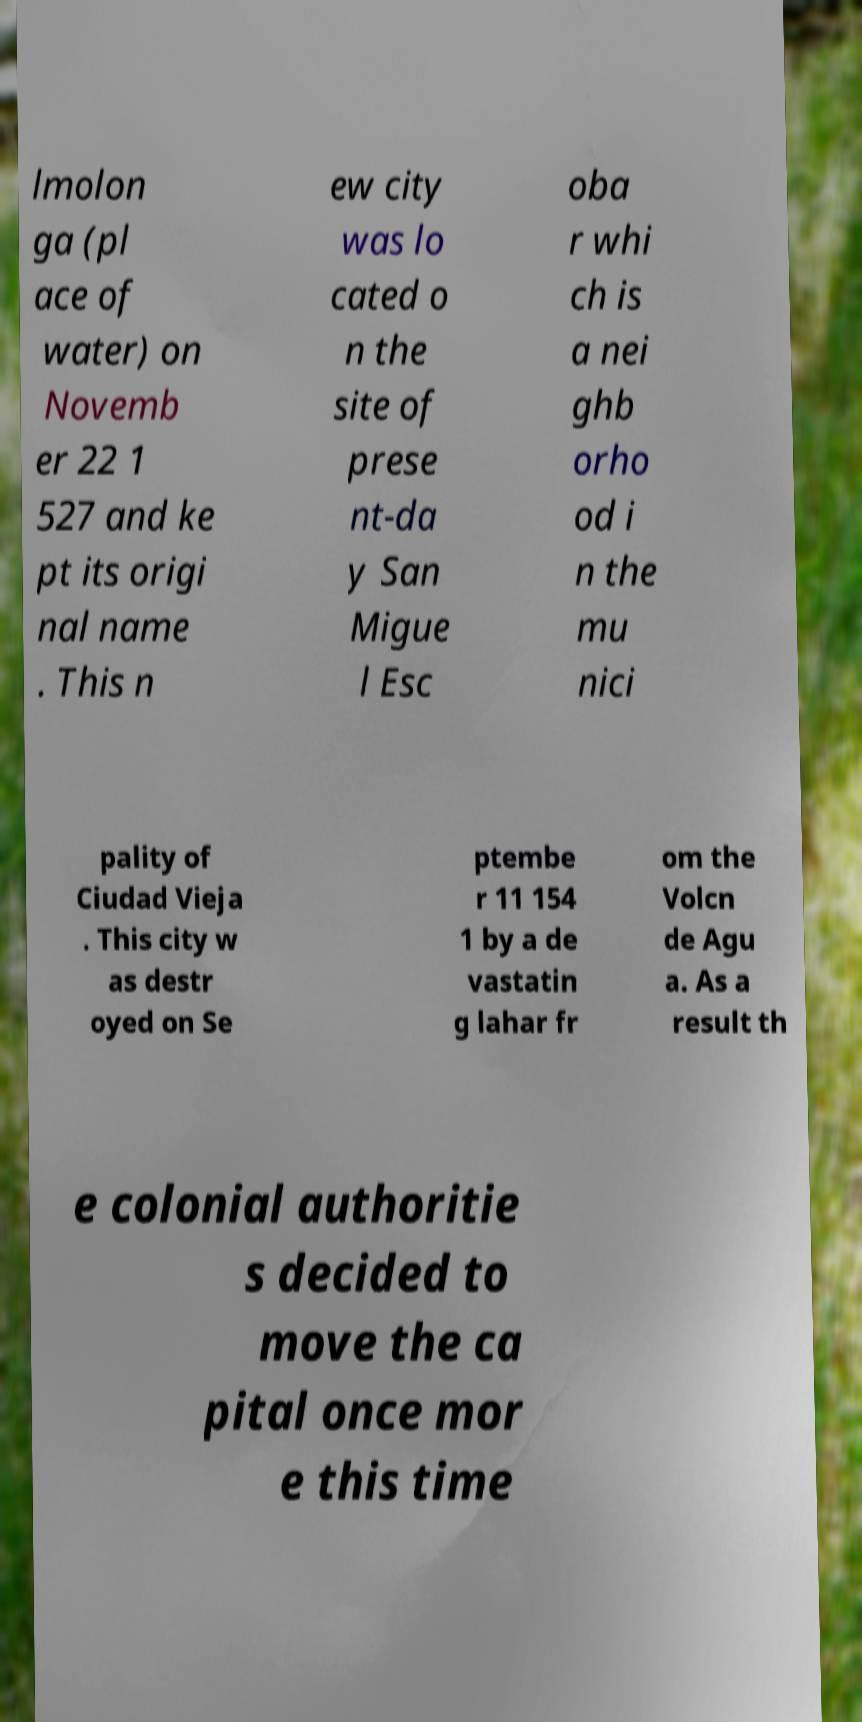Could you extract and type out the text from this image? lmolon ga (pl ace of water) on Novemb er 22 1 527 and ke pt its origi nal name . This n ew city was lo cated o n the site of prese nt-da y San Migue l Esc oba r whi ch is a nei ghb orho od i n the mu nici pality of Ciudad Vieja . This city w as destr oyed on Se ptembe r 11 154 1 by a de vastatin g lahar fr om the Volcn de Agu a. As a result th e colonial authoritie s decided to move the ca pital once mor e this time 